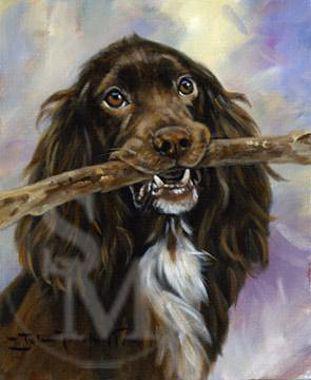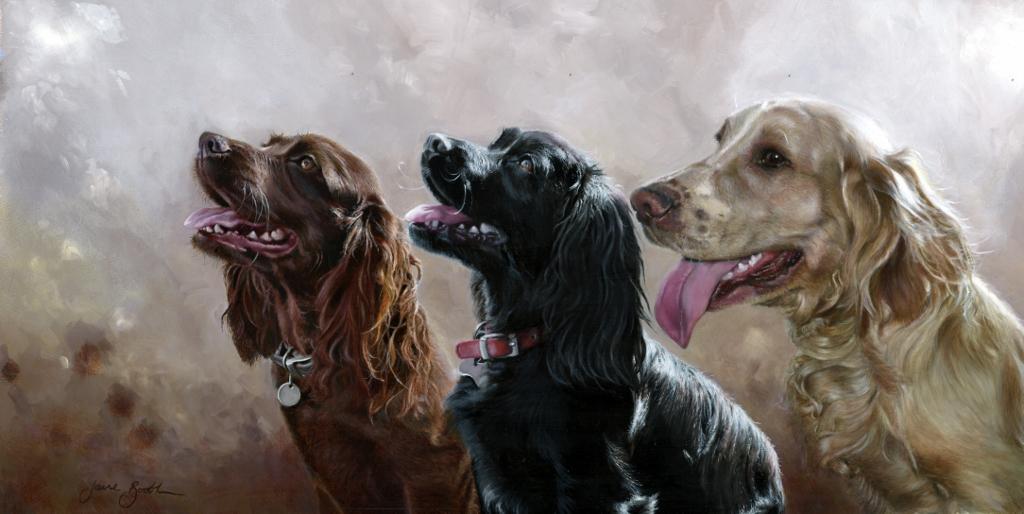The first image is the image on the left, the second image is the image on the right. Examine the images to the left and right. Is the description "All of the dogs are black." accurate? Answer yes or no. No. The first image is the image on the left, the second image is the image on the right. Given the left and right images, does the statement "All images show only dogs with black fur on their faces." hold true? Answer yes or no. No. 